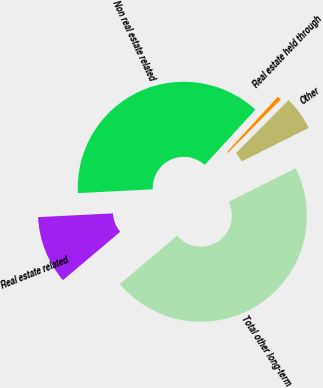Convert chart to OTSL. <chart><loc_0><loc_0><loc_500><loc_500><pie_chart><fcel>Real estate related<fcel>Non real estate related<fcel>Real estate held through<fcel>Other<fcel>Total other long-term<nl><fcel>10.35%<fcel>37.61%<fcel>0.62%<fcel>5.18%<fcel>46.23%<nl></chart> 